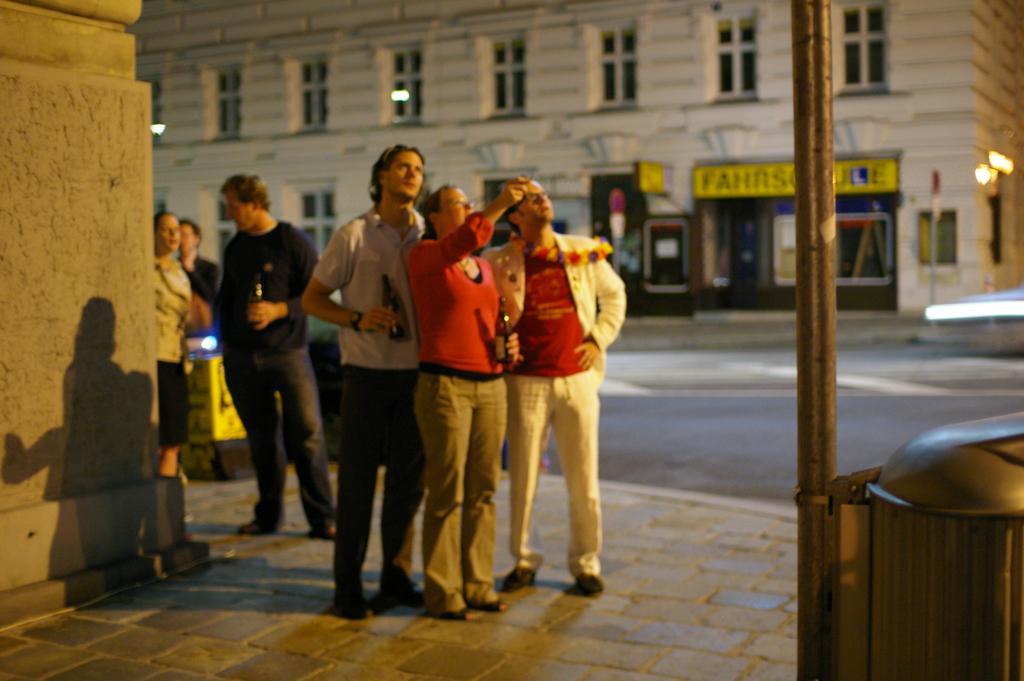How would you summarize this image in a sentence or two? In this image in the middle, there is a woman, she wears a t shirt, trouser, on the left there is a man, he wears a t shirt, trouser, shoes, to the right there is a man, he wears a suit, t shirt, trouser, shoes, they are standing. On the left there is a man, he wears a t shirt, trouser, he is holding a bottle and there is a woman, he wears a dress. In the background there is a building, light, a poster, some people, road. At the bottom there is a pole, wall. 